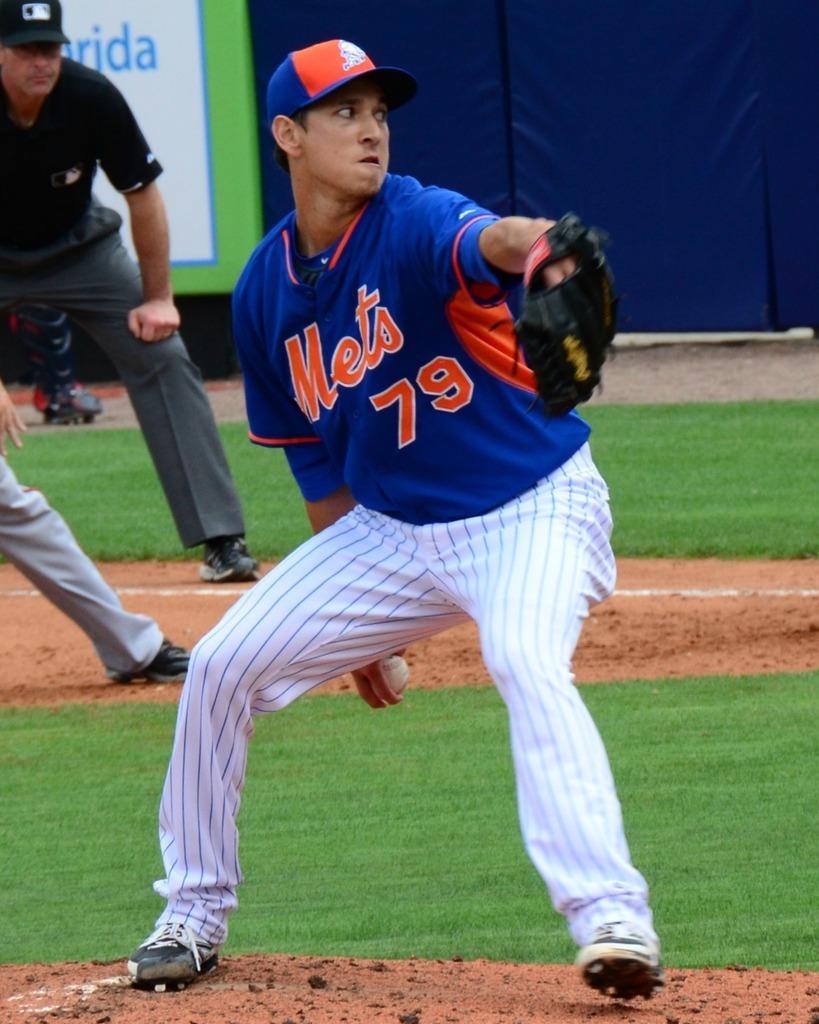Please provide a concise description of this image. In this image in the front there is a man standing and holding a ball and holding a glove in his hand. In the background there are persons standing and there is grass on the ground and there is a curtain which is blue in colour and there is a board with some text written on it. 